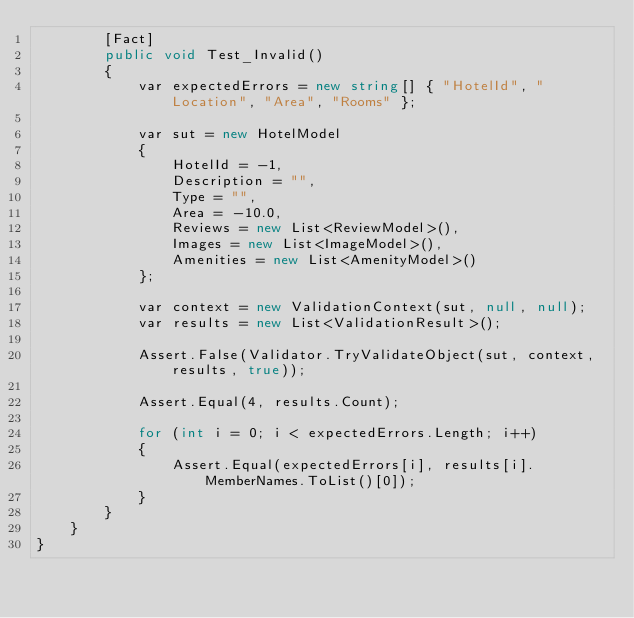Convert code to text. <code><loc_0><loc_0><loc_500><loc_500><_C#_>        [Fact]
        public void Test_Invalid()
        {
            var expectedErrors = new string[] { "HotelId", "Location", "Area", "Rooms" };

            var sut = new HotelModel
            {
                HotelId = -1,
                Description = "",
                Type = "",
                Area = -10.0,
                Reviews = new List<ReviewModel>(),
                Images = new List<ImageModel>(),
                Amenities = new List<AmenityModel>()
            };

            var context = new ValidationContext(sut, null, null);
            var results = new List<ValidationResult>();

            Assert.False(Validator.TryValidateObject(sut, context, results, true));

            Assert.Equal(4, results.Count);

            for (int i = 0; i < expectedErrors.Length; i++)
            {
                Assert.Equal(expectedErrors[i], results[i].MemberNames.ToList()[0]);
            }
        }
    }
}
</code> 